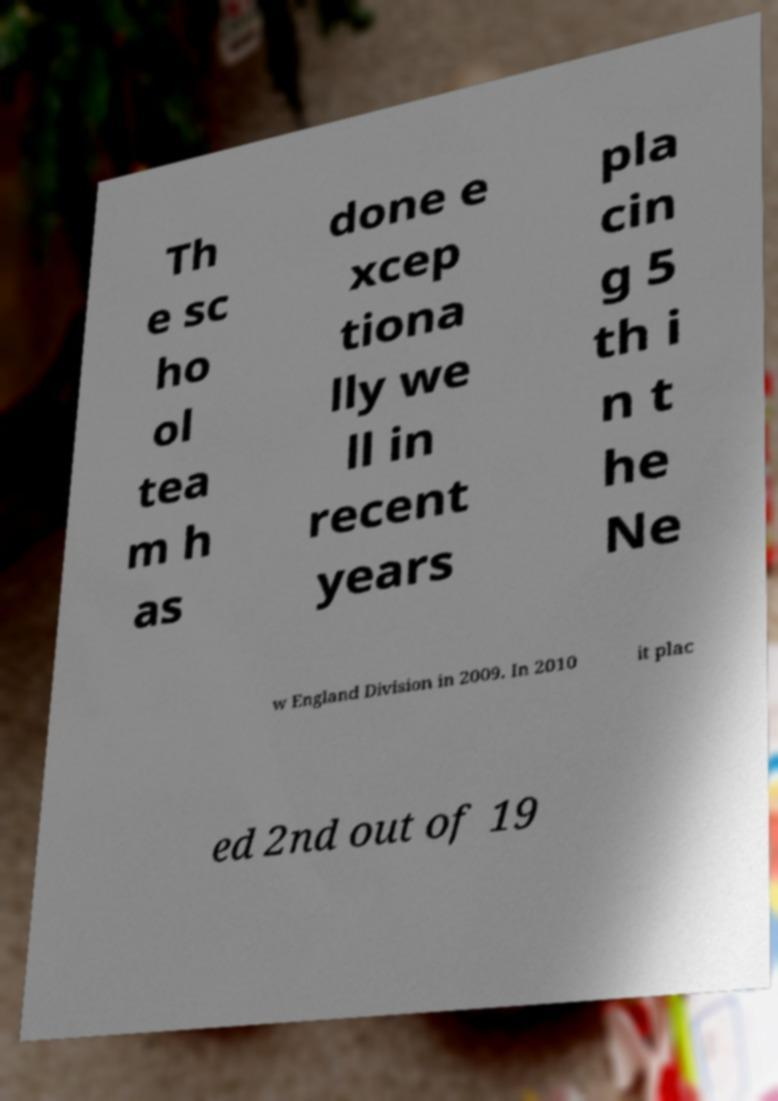Can you accurately transcribe the text from the provided image for me? Th e sc ho ol tea m h as done e xcep tiona lly we ll in recent years pla cin g 5 th i n t he Ne w England Division in 2009. In 2010 it plac ed 2nd out of 19 